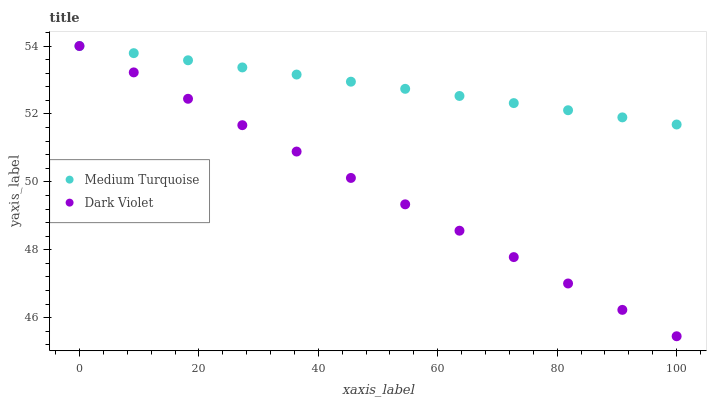Does Dark Violet have the minimum area under the curve?
Answer yes or no. Yes. Does Medium Turquoise have the maximum area under the curve?
Answer yes or no. Yes. Does Medium Turquoise have the minimum area under the curve?
Answer yes or no. No. Is Medium Turquoise the smoothest?
Answer yes or no. Yes. Is Dark Violet the roughest?
Answer yes or no. Yes. Is Medium Turquoise the roughest?
Answer yes or no. No. Does Dark Violet have the lowest value?
Answer yes or no. Yes. Does Medium Turquoise have the lowest value?
Answer yes or no. No. Does Medium Turquoise have the highest value?
Answer yes or no. Yes. Does Medium Turquoise intersect Dark Violet?
Answer yes or no. Yes. Is Medium Turquoise less than Dark Violet?
Answer yes or no. No. Is Medium Turquoise greater than Dark Violet?
Answer yes or no. No. 